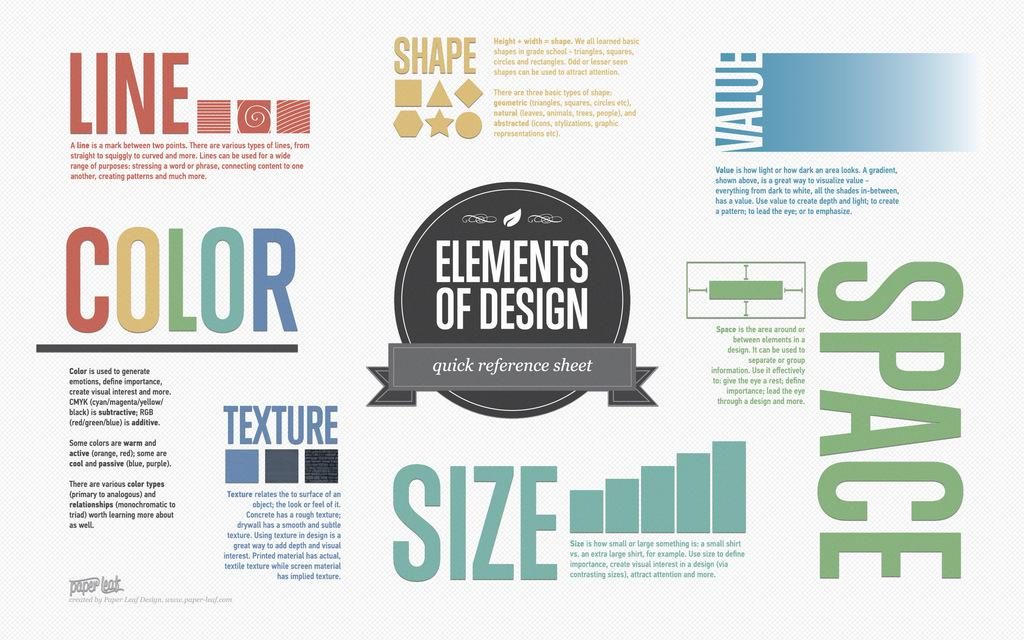What is present in the image that contains information or visuals? There is a poster in the image. What can be found on the poster besides images or graphics? The poster contains text. Are there any non-textual elements on the poster? Yes, the poster contains symbols. What type of meal is being prepared in the image? There is no meal preparation visible in the image; it only contains a poster with text and symbols. 